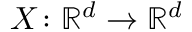<formula> <loc_0><loc_0><loc_500><loc_500>X \colon { \mathbb { R } ^ { d } } \to { \mathbb { R } ^ { d } }</formula> 